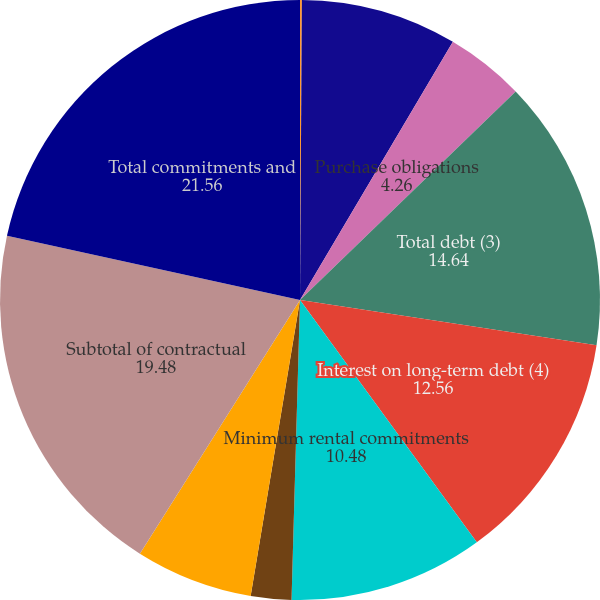<chart> <loc_0><loc_0><loc_500><loc_500><pie_chart><fcel>Performance bonds and<fcel>Subtotal of commitment<fcel>Purchase obligations<fcel>Total debt (3)<fcel>Interest on long-term debt (4)<fcel>Minimum rental commitments<fcel>Capital leases (3)<fcel>Imputed interest on capital<fcel>Subtotal of contractual<fcel>Total commitments and<nl><fcel>0.1%<fcel>8.41%<fcel>4.26%<fcel>14.64%<fcel>12.56%<fcel>10.48%<fcel>2.18%<fcel>6.33%<fcel>19.48%<fcel>21.56%<nl></chart> 